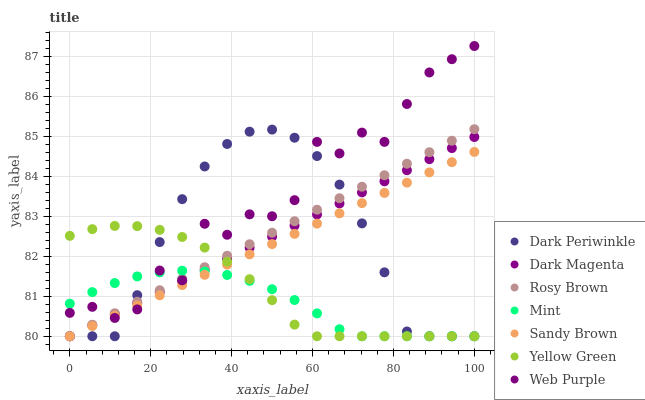Does Mint have the minimum area under the curve?
Answer yes or no. Yes. Does Web Purple have the maximum area under the curve?
Answer yes or no. Yes. Does Rosy Brown have the minimum area under the curve?
Answer yes or no. No. Does Rosy Brown have the maximum area under the curve?
Answer yes or no. No. Is Dark Magenta the smoothest?
Answer yes or no. Yes. Is Web Purple the roughest?
Answer yes or no. Yes. Is Mint the smoothest?
Answer yes or no. No. Is Mint the roughest?
Answer yes or no. No. Does Yellow Green have the lowest value?
Answer yes or no. Yes. Does Web Purple have the lowest value?
Answer yes or no. No. Does Web Purple have the highest value?
Answer yes or no. Yes. Does Rosy Brown have the highest value?
Answer yes or no. No. Does Mint intersect Web Purple?
Answer yes or no. Yes. Is Mint less than Web Purple?
Answer yes or no. No. Is Mint greater than Web Purple?
Answer yes or no. No. 